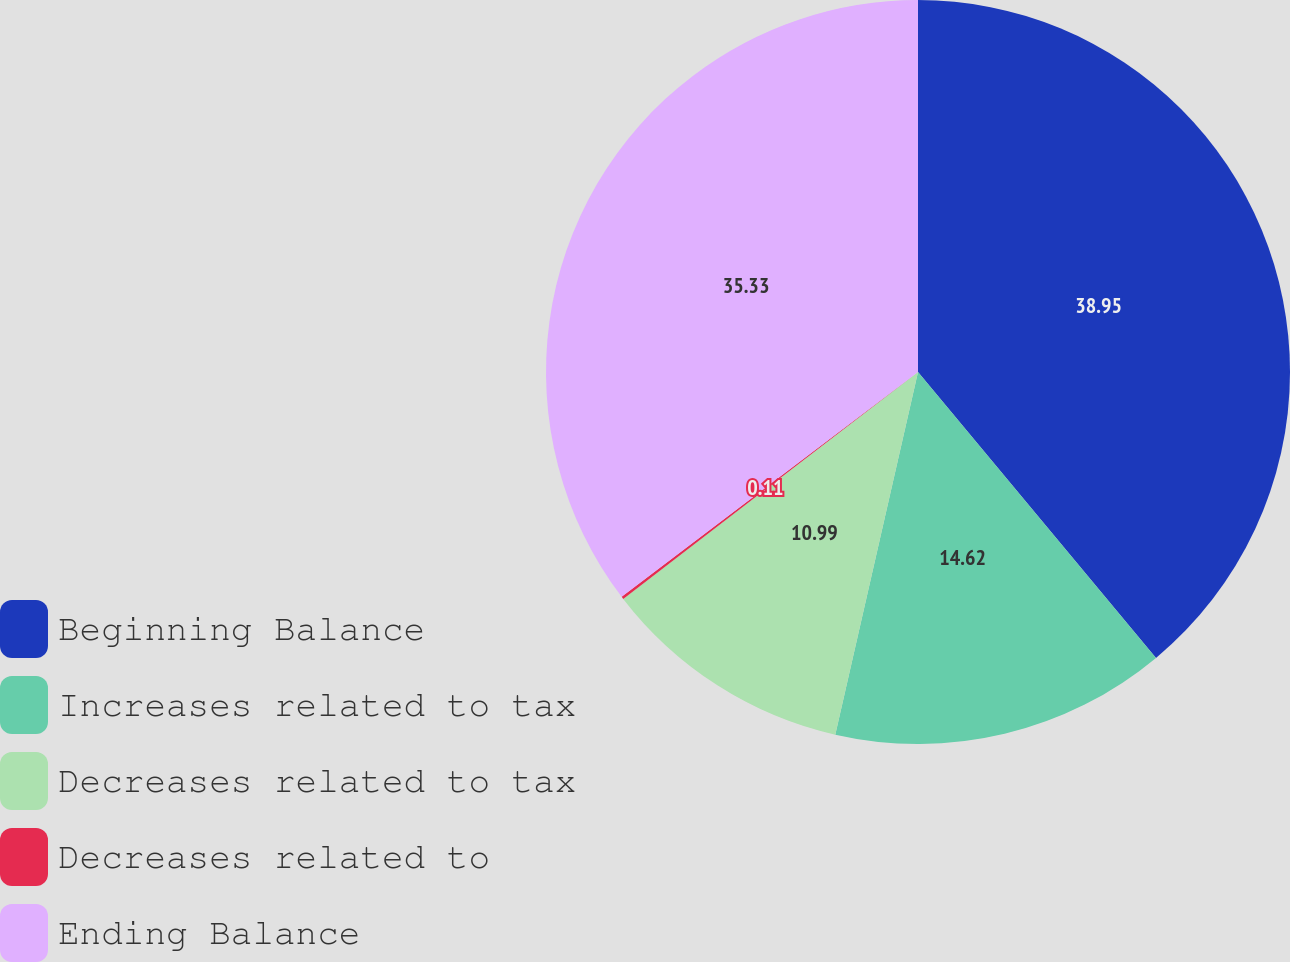Convert chart. <chart><loc_0><loc_0><loc_500><loc_500><pie_chart><fcel>Beginning Balance<fcel>Increases related to tax<fcel>Decreases related to tax<fcel>Decreases related to<fcel>Ending Balance<nl><fcel>38.95%<fcel>14.62%<fcel>10.99%<fcel>0.11%<fcel>35.33%<nl></chart> 